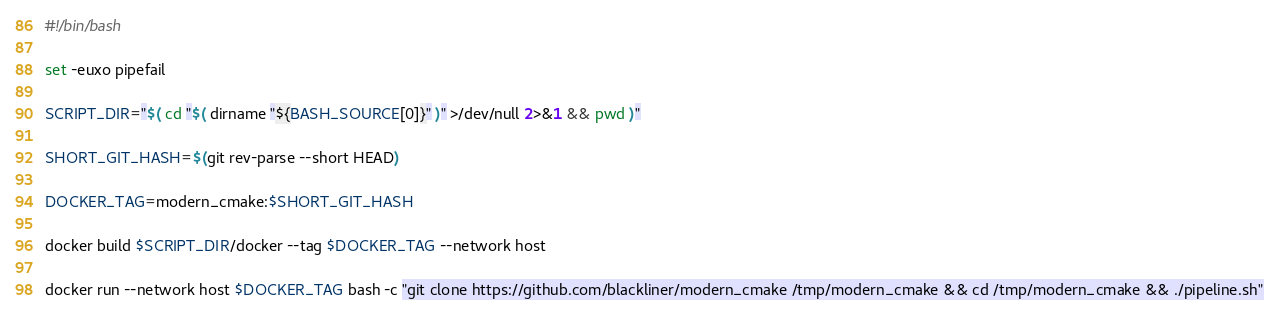<code> <loc_0><loc_0><loc_500><loc_500><_Bash_>#!/bin/bash

set -euxo pipefail

SCRIPT_DIR="$( cd "$( dirname "${BASH_SOURCE[0]}" )" >/dev/null 2>&1 && pwd )"

SHORT_GIT_HASH=$(git rev-parse --short HEAD)

DOCKER_TAG=modern_cmake:$SHORT_GIT_HASH

docker build $SCRIPT_DIR/docker --tag $DOCKER_TAG --network host

docker run --network host $DOCKER_TAG bash -c "git clone https://github.com/blackliner/modern_cmake /tmp/modern_cmake && cd /tmp/modern_cmake && ./pipeline.sh"
</code> 